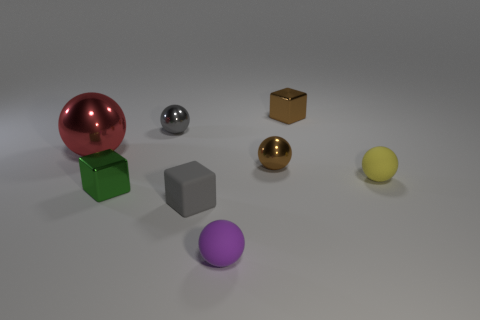Subtract all tiny matte balls. How many balls are left? 3 Subtract all yellow spheres. How many spheres are left? 4 Add 1 large cyan matte blocks. How many objects exist? 9 Subtract 1 blocks. How many blocks are left? 2 Subtract all cubes. How many objects are left? 5 Subtract all cyan balls. Subtract all blue blocks. How many balls are left? 5 Add 1 small yellow cylinders. How many small yellow cylinders exist? 1 Subtract 0 purple blocks. How many objects are left? 8 Subtract all tiny green metallic cubes. Subtract all green metallic cubes. How many objects are left? 6 Add 3 yellow matte objects. How many yellow matte objects are left? 4 